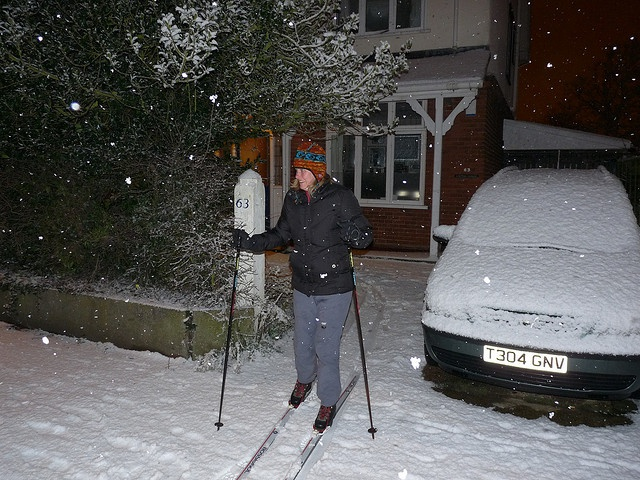Describe the objects in this image and their specific colors. I can see car in black, darkgray, gray, and lightgray tones, people in black, gray, maroon, and darkgray tones, and skis in black, darkgray, gray, lightgray, and purple tones in this image. 